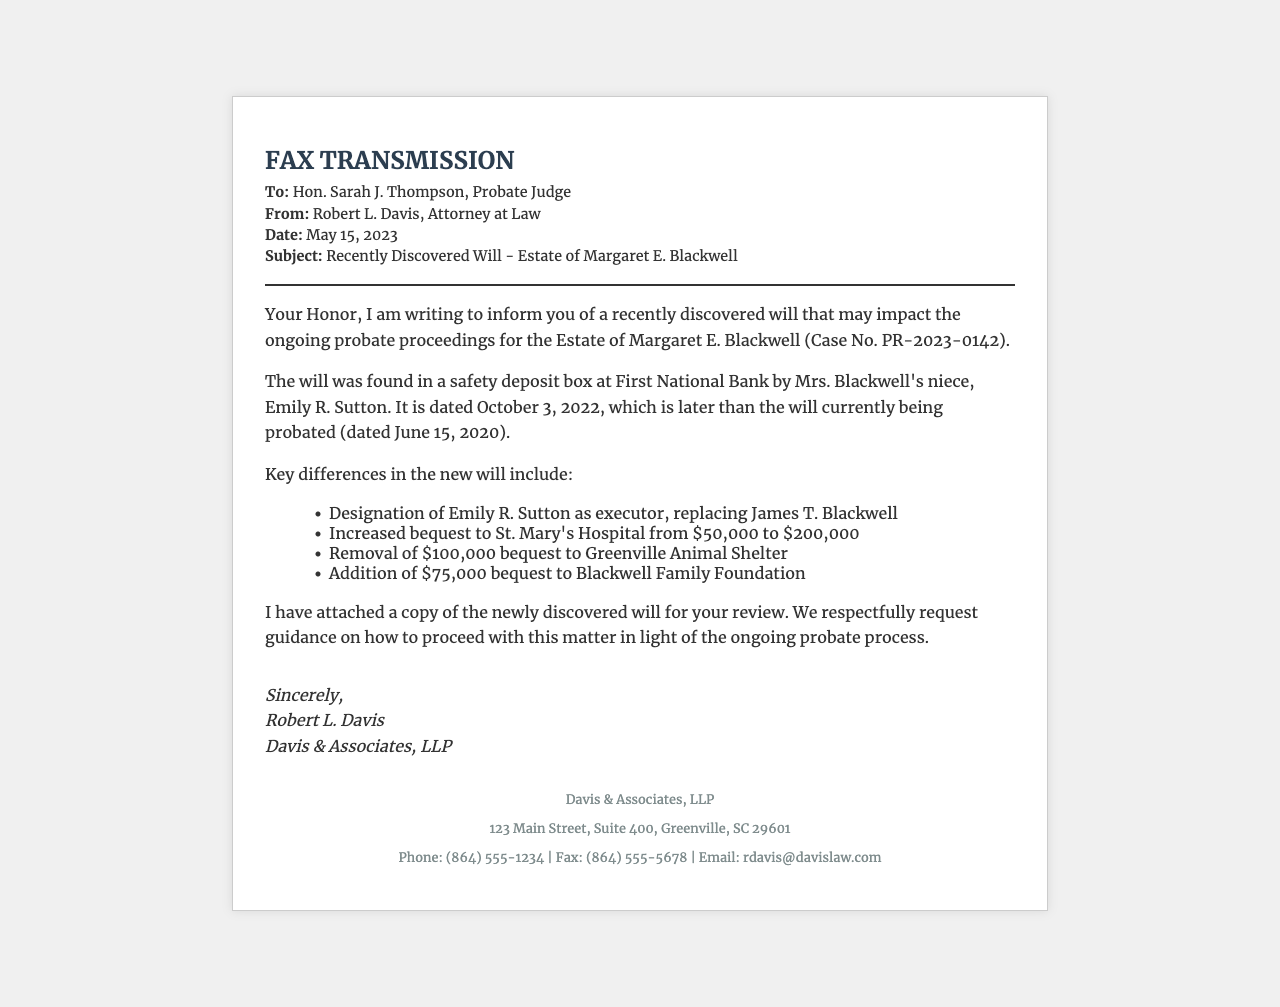What is the date of the newly discovered will? The date of the newly discovered will is explicitly stated in the document as October 3, 2022.
Answer: October 3, 2022 Who is the executor designated in the new will? The executor designated in the new will is mentioned in the document as Emily R. Sutton.
Answer: Emily R. Sutton What is the increased bequest amount to St. Mary's Hospital? The new bequest amount to St. Mary's Hospital is compared to the previous amount, which indicates it is now $200,000.
Answer: $200,000 What is the relationship of Emily R. Sutton to Margaret E. Blackwell? The document indicates that Emily R. Sutton is the niece of Margaret E. Blackwell.
Answer: Niece Which bequest was removed from the new will? The document lists the removal of the bequest to Greenville Animal Shelter as a key difference.
Answer: Greenville Animal Shelter What is the fax transmission date? The fax transmission date is stated at the top of the document as May 15, 2023.
Answer: May 15, 2023 Who sent the fax? The sender of the fax is identified in the document as Robert L. Davis.
Answer: Robert L. Davis What is the case number for the probate proceeding? The case number is explicitly stated in the document as PR-2023-0142.
Answer: PR-2023-0142 What is the closing line in the fax? The closing line includes a formal farewell followed by the sender's name and law firm; the line states "Sincerely."
Answer: Sincerely 